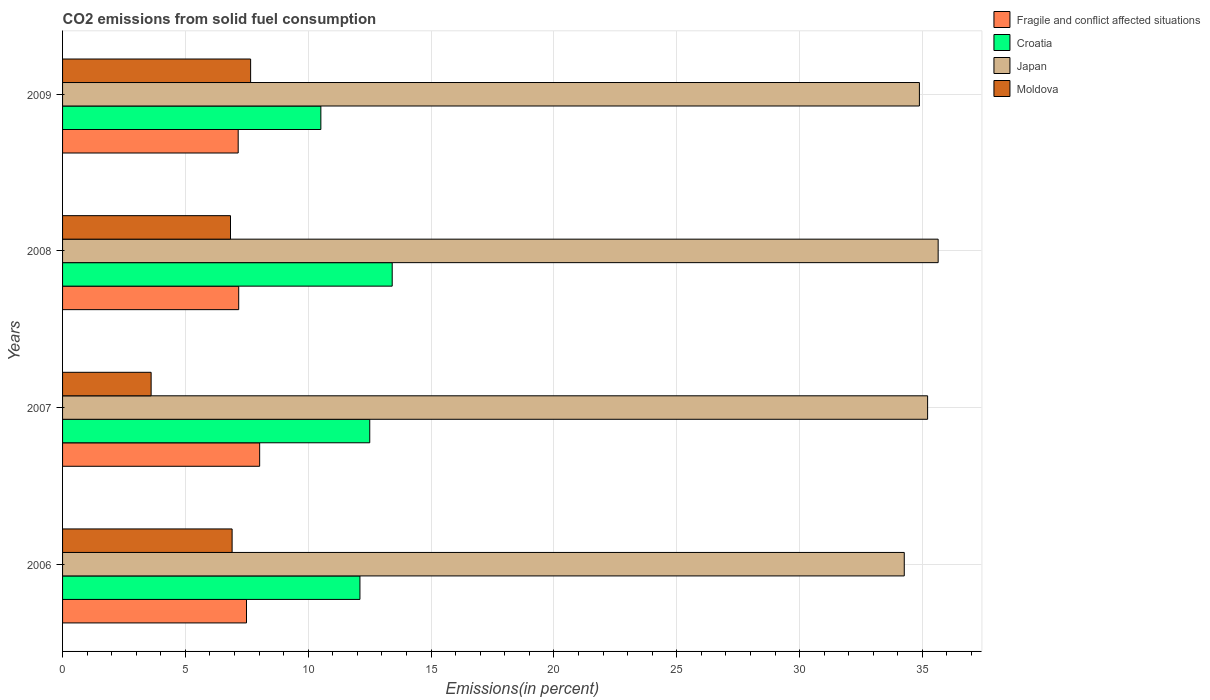Are the number of bars on each tick of the Y-axis equal?
Your answer should be very brief. Yes. How many bars are there on the 1st tick from the top?
Your answer should be compact. 4. What is the total CO2 emitted in Moldova in 2006?
Provide a succinct answer. 6.9. Across all years, what is the maximum total CO2 emitted in Croatia?
Your response must be concise. 13.42. Across all years, what is the minimum total CO2 emitted in Croatia?
Offer a terse response. 10.51. In which year was the total CO2 emitted in Japan maximum?
Make the answer very short. 2008. In which year was the total CO2 emitted in Fragile and conflict affected situations minimum?
Give a very brief answer. 2009. What is the total total CO2 emitted in Moldova in the graph?
Keep it short and to the point. 25. What is the difference between the total CO2 emitted in Moldova in 2006 and that in 2007?
Make the answer very short. 3.3. What is the difference between the total CO2 emitted in Fragile and conflict affected situations in 2006 and the total CO2 emitted in Moldova in 2008?
Make the answer very short. 0.65. What is the average total CO2 emitted in Moldova per year?
Give a very brief answer. 6.25. In the year 2009, what is the difference between the total CO2 emitted in Croatia and total CO2 emitted in Japan?
Give a very brief answer. -24.36. In how many years, is the total CO2 emitted in Fragile and conflict affected situations greater than 10 %?
Make the answer very short. 0. What is the ratio of the total CO2 emitted in Japan in 2006 to that in 2007?
Offer a very short reply. 0.97. Is the total CO2 emitted in Fragile and conflict affected situations in 2008 less than that in 2009?
Give a very brief answer. No. What is the difference between the highest and the second highest total CO2 emitted in Croatia?
Make the answer very short. 0.91. What is the difference between the highest and the lowest total CO2 emitted in Croatia?
Offer a very short reply. 2.9. In how many years, is the total CO2 emitted in Japan greater than the average total CO2 emitted in Japan taken over all years?
Your answer should be very brief. 2. Is the sum of the total CO2 emitted in Japan in 2006 and 2009 greater than the maximum total CO2 emitted in Moldova across all years?
Your answer should be very brief. Yes. Is it the case that in every year, the sum of the total CO2 emitted in Japan and total CO2 emitted in Croatia is greater than the sum of total CO2 emitted in Moldova and total CO2 emitted in Fragile and conflict affected situations?
Give a very brief answer. No. What does the 4th bar from the top in 2009 represents?
Your answer should be compact. Fragile and conflict affected situations. How many bars are there?
Give a very brief answer. 16. What is the difference between two consecutive major ticks on the X-axis?
Ensure brevity in your answer.  5. Does the graph contain any zero values?
Provide a succinct answer. No. Does the graph contain grids?
Make the answer very short. Yes. Where does the legend appear in the graph?
Provide a short and direct response. Top right. What is the title of the graph?
Offer a terse response. CO2 emissions from solid fuel consumption. Does "West Bank and Gaza" appear as one of the legend labels in the graph?
Keep it short and to the point. No. What is the label or title of the X-axis?
Your answer should be compact. Emissions(in percent). What is the Emissions(in percent) in Fragile and conflict affected situations in 2006?
Offer a terse response. 7.49. What is the Emissions(in percent) in Croatia in 2006?
Give a very brief answer. 12.1. What is the Emissions(in percent) of Japan in 2006?
Provide a short and direct response. 34.26. What is the Emissions(in percent) of Moldova in 2006?
Your answer should be compact. 6.9. What is the Emissions(in percent) of Fragile and conflict affected situations in 2007?
Provide a short and direct response. 8.02. What is the Emissions(in percent) of Croatia in 2007?
Keep it short and to the point. 12.5. What is the Emissions(in percent) in Japan in 2007?
Provide a succinct answer. 35.21. What is the Emissions(in percent) in Moldova in 2007?
Offer a terse response. 3.61. What is the Emissions(in percent) in Fragile and conflict affected situations in 2008?
Offer a terse response. 7.17. What is the Emissions(in percent) in Croatia in 2008?
Ensure brevity in your answer.  13.42. What is the Emissions(in percent) of Japan in 2008?
Provide a short and direct response. 35.64. What is the Emissions(in percent) of Moldova in 2008?
Give a very brief answer. 6.84. What is the Emissions(in percent) in Fragile and conflict affected situations in 2009?
Keep it short and to the point. 7.15. What is the Emissions(in percent) of Croatia in 2009?
Ensure brevity in your answer.  10.51. What is the Emissions(in percent) in Japan in 2009?
Offer a very short reply. 34.88. What is the Emissions(in percent) in Moldova in 2009?
Your answer should be very brief. 7.66. Across all years, what is the maximum Emissions(in percent) in Fragile and conflict affected situations?
Provide a short and direct response. 8.02. Across all years, what is the maximum Emissions(in percent) of Croatia?
Give a very brief answer. 13.42. Across all years, what is the maximum Emissions(in percent) of Japan?
Give a very brief answer. 35.64. Across all years, what is the maximum Emissions(in percent) of Moldova?
Your answer should be compact. 7.66. Across all years, what is the minimum Emissions(in percent) in Fragile and conflict affected situations?
Give a very brief answer. 7.15. Across all years, what is the minimum Emissions(in percent) of Croatia?
Your response must be concise. 10.51. Across all years, what is the minimum Emissions(in percent) of Japan?
Provide a succinct answer. 34.26. Across all years, what is the minimum Emissions(in percent) of Moldova?
Your response must be concise. 3.61. What is the total Emissions(in percent) of Fragile and conflict affected situations in the graph?
Make the answer very short. 29.83. What is the total Emissions(in percent) in Croatia in the graph?
Your answer should be compact. 48.54. What is the total Emissions(in percent) of Japan in the graph?
Ensure brevity in your answer.  139.99. What is the total Emissions(in percent) of Moldova in the graph?
Offer a very short reply. 25. What is the difference between the Emissions(in percent) of Fragile and conflict affected situations in 2006 and that in 2007?
Your response must be concise. -0.54. What is the difference between the Emissions(in percent) in Croatia in 2006 and that in 2007?
Keep it short and to the point. -0.4. What is the difference between the Emissions(in percent) of Japan in 2006 and that in 2007?
Offer a terse response. -0.95. What is the difference between the Emissions(in percent) in Moldova in 2006 and that in 2007?
Your answer should be compact. 3.3. What is the difference between the Emissions(in percent) of Fragile and conflict affected situations in 2006 and that in 2008?
Keep it short and to the point. 0.32. What is the difference between the Emissions(in percent) in Croatia in 2006 and that in 2008?
Give a very brief answer. -1.31. What is the difference between the Emissions(in percent) of Japan in 2006 and that in 2008?
Provide a succinct answer. -1.38. What is the difference between the Emissions(in percent) in Moldova in 2006 and that in 2008?
Provide a short and direct response. 0.07. What is the difference between the Emissions(in percent) of Fragile and conflict affected situations in 2006 and that in 2009?
Keep it short and to the point. 0.34. What is the difference between the Emissions(in percent) in Croatia in 2006 and that in 2009?
Offer a terse response. 1.59. What is the difference between the Emissions(in percent) of Japan in 2006 and that in 2009?
Offer a terse response. -0.62. What is the difference between the Emissions(in percent) of Moldova in 2006 and that in 2009?
Make the answer very short. -0.75. What is the difference between the Emissions(in percent) in Fragile and conflict affected situations in 2007 and that in 2008?
Your response must be concise. 0.85. What is the difference between the Emissions(in percent) of Croatia in 2007 and that in 2008?
Your answer should be very brief. -0.91. What is the difference between the Emissions(in percent) in Japan in 2007 and that in 2008?
Provide a succinct answer. -0.43. What is the difference between the Emissions(in percent) in Moldova in 2007 and that in 2008?
Your answer should be compact. -3.23. What is the difference between the Emissions(in percent) of Fragile and conflict affected situations in 2007 and that in 2009?
Make the answer very short. 0.87. What is the difference between the Emissions(in percent) in Croatia in 2007 and that in 2009?
Your answer should be compact. 1.99. What is the difference between the Emissions(in percent) in Japan in 2007 and that in 2009?
Your answer should be compact. 0.33. What is the difference between the Emissions(in percent) in Moldova in 2007 and that in 2009?
Your response must be concise. -4.05. What is the difference between the Emissions(in percent) in Fragile and conflict affected situations in 2008 and that in 2009?
Offer a very short reply. 0.02. What is the difference between the Emissions(in percent) in Croatia in 2008 and that in 2009?
Your answer should be very brief. 2.9. What is the difference between the Emissions(in percent) of Japan in 2008 and that in 2009?
Ensure brevity in your answer.  0.76. What is the difference between the Emissions(in percent) of Moldova in 2008 and that in 2009?
Ensure brevity in your answer.  -0.82. What is the difference between the Emissions(in percent) in Fragile and conflict affected situations in 2006 and the Emissions(in percent) in Croatia in 2007?
Offer a very short reply. -5.02. What is the difference between the Emissions(in percent) of Fragile and conflict affected situations in 2006 and the Emissions(in percent) of Japan in 2007?
Offer a terse response. -27.72. What is the difference between the Emissions(in percent) of Fragile and conflict affected situations in 2006 and the Emissions(in percent) of Moldova in 2007?
Offer a very short reply. 3.88. What is the difference between the Emissions(in percent) of Croatia in 2006 and the Emissions(in percent) of Japan in 2007?
Make the answer very short. -23.11. What is the difference between the Emissions(in percent) of Croatia in 2006 and the Emissions(in percent) of Moldova in 2007?
Give a very brief answer. 8.5. What is the difference between the Emissions(in percent) of Japan in 2006 and the Emissions(in percent) of Moldova in 2007?
Offer a very short reply. 30.66. What is the difference between the Emissions(in percent) of Fragile and conflict affected situations in 2006 and the Emissions(in percent) of Croatia in 2008?
Provide a short and direct response. -5.93. What is the difference between the Emissions(in percent) in Fragile and conflict affected situations in 2006 and the Emissions(in percent) in Japan in 2008?
Make the answer very short. -28.15. What is the difference between the Emissions(in percent) in Fragile and conflict affected situations in 2006 and the Emissions(in percent) in Moldova in 2008?
Your answer should be compact. 0.65. What is the difference between the Emissions(in percent) in Croatia in 2006 and the Emissions(in percent) in Japan in 2008?
Ensure brevity in your answer.  -23.54. What is the difference between the Emissions(in percent) of Croatia in 2006 and the Emissions(in percent) of Moldova in 2008?
Ensure brevity in your answer.  5.27. What is the difference between the Emissions(in percent) in Japan in 2006 and the Emissions(in percent) in Moldova in 2008?
Your answer should be compact. 27.43. What is the difference between the Emissions(in percent) in Fragile and conflict affected situations in 2006 and the Emissions(in percent) in Croatia in 2009?
Offer a terse response. -3.03. What is the difference between the Emissions(in percent) in Fragile and conflict affected situations in 2006 and the Emissions(in percent) in Japan in 2009?
Your answer should be compact. -27.39. What is the difference between the Emissions(in percent) in Fragile and conflict affected situations in 2006 and the Emissions(in percent) in Moldova in 2009?
Provide a short and direct response. -0.17. What is the difference between the Emissions(in percent) of Croatia in 2006 and the Emissions(in percent) of Japan in 2009?
Offer a terse response. -22.77. What is the difference between the Emissions(in percent) in Croatia in 2006 and the Emissions(in percent) in Moldova in 2009?
Ensure brevity in your answer.  4.45. What is the difference between the Emissions(in percent) of Japan in 2006 and the Emissions(in percent) of Moldova in 2009?
Keep it short and to the point. 26.61. What is the difference between the Emissions(in percent) of Fragile and conflict affected situations in 2007 and the Emissions(in percent) of Croatia in 2008?
Your answer should be compact. -5.4. What is the difference between the Emissions(in percent) of Fragile and conflict affected situations in 2007 and the Emissions(in percent) of Japan in 2008?
Offer a terse response. -27.62. What is the difference between the Emissions(in percent) of Fragile and conflict affected situations in 2007 and the Emissions(in percent) of Moldova in 2008?
Your answer should be compact. 1.19. What is the difference between the Emissions(in percent) of Croatia in 2007 and the Emissions(in percent) of Japan in 2008?
Offer a very short reply. -23.14. What is the difference between the Emissions(in percent) in Croatia in 2007 and the Emissions(in percent) in Moldova in 2008?
Give a very brief answer. 5.67. What is the difference between the Emissions(in percent) in Japan in 2007 and the Emissions(in percent) in Moldova in 2008?
Your answer should be very brief. 28.38. What is the difference between the Emissions(in percent) in Fragile and conflict affected situations in 2007 and the Emissions(in percent) in Croatia in 2009?
Ensure brevity in your answer.  -2.49. What is the difference between the Emissions(in percent) in Fragile and conflict affected situations in 2007 and the Emissions(in percent) in Japan in 2009?
Provide a succinct answer. -26.86. What is the difference between the Emissions(in percent) in Fragile and conflict affected situations in 2007 and the Emissions(in percent) in Moldova in 2009?
Give a very brief answer. 0.37. What is the difference between the Emissions(in percent) of Croatia in 2007 and the Emissions(in percent) of Japan in 2009?
Ensure brevity in your answer.  -22.37. What is the difference between the Emissions(in percent) of Croatia in 2007 and the Emissions(in percent) of Moldova in 2009?
Provide a short and direct response. 4.85. What is the difference between the Emissions(in percent) of Japan in 2007 and the Emissions(in percent) of Moldova in 2009?
Offer a very short reply. 27.56. What is the difference between the Emissions(in percent) in Fragile and conflict affected situations in 2008 and the Emissions(in percent) in Croatia in 2009?
Give a very brief answer. -3.34. What is the difference between the Emissions(in percent) of Fragile and conflict affected situations in 2008 and the Emissions(in percent) of Japan in 2009?
Your answer should be compact. -27.71. What is the difference between the Emissions(in percent) of Fragile and conflict affected situations in 2008 and the Emissions(in percent) of Moldova in 2009?
Give a very brief answer. -0.49. What is the difference between the Emissions(in percent) in Croatia in 2008 and the Emissions(in percent) in Japan in 2009?
Provide a succinct answer. -21.46. What is the difference between the Emissions(in percent) of Croatia in 2008 and the Emissions(in percent) of Moldova in 2009?
Your answer should be very brief. 5.76. What is the difference between the Emissions(in percent) of Japan in 2008 and the Emissions(in percent) of Moldova in 2009?
Provide a short and direct response. 27.99. What is the average Emissions(in percent) in Fragile and conflict affected situations per year?
Ensure brevity in your answer.  7.46. What is the average Emissions(in percent) in Croatia per year?
Your answer should be compact. 12.13. What is the average Emissions(in percent) of Japan per year?
Provide a short and direct response. 35. What is the average Emissions(in percent) of Moldova per year?
Offer a very short reply. 6.25. In the year 2006, what is the difference between the Emissions(in percent) of Fragile and conflict affected situations and Emissions(in percent) of Croatia?
Make the answer very short. -4.62. In the year 2006, what is the difference between the Emissions(in percent) in Fragile and conflict affected situations and Emissions(in percent) in Japan?
Give a very brief answer. -26.77. In the year 2006, what is the difference between the Emissions(in percent) in Fragile and conflict affected situations and Emissions(in percent) in Moldova?
Your answer should be compact. 0.59. In the year 2006, what is the difference between the Emissions(in percent) in Croatia and Emissions(in percent) in Japan?
Provide a short and direct response. -22.16. In the year 2006, what is the difference between the Emissions(in percent) in Croatia and Emissions(in percent) in Moldova?
Provide a short and direct response. 5.2. In the year 2006, what is the difference between the Emissions(in percent) in Japan and Emissions(in percent) in Moldova?
Provide a succinct answer. 27.36. In the year 2007, what is the difference between the Emissions(in percent) in Fragile and conflict affected situations and Emissions(in percent) in Croatia?
Offer a very short reply. -4.48. In the year 2007, what is the difference between the Emissions(in percent) in Fragile and conflict affected situations and Emissions(in percent) in Japan?
Ensure brevity in your answer.  -27.19. In the year 2007, what is the difference between the Emissions(in percent) of Fragile and conflict affected situations and Emissions(in percent) of Moldova?
Make the answer very short. 4.42. In the year 2007, what is the difference between the Emissions(in percent) of Croatia and Emissions(in percent) of Japan?
Offer a very short reply. -22.71. In the year 2007, what is the difference between the Emissions(in percent) of Croatia and Emissions(in percent) of Moldova?
Give a very brief answer. 8.9. In the year 2007, what is the difference between the Emissions(in percent) of Japan and Emissions(in percent) of Moldova?
Give a very brief answer. 31.61. In the year 2008, what is the difference between the Emissions(in percent) in Fragile and conflict affected situations and Emissions(in percent) in Croatia?
Give a very brief answer. -6.25. In the year 2008, what is the difference between the Emissions(in percent) of Fragile and conflict affected situations and Emissions(in percent) of Japan?
Your response must be concise. -28.47. In the year 2008, what is the difference between the Emissions(in percent) in Fragile and conflict affected situations and Emissions(in percent) in Moldova?
Your answer should be very brief. 0.33. In the year 2008, what is the difference between the Emissions(in percent) of Croatia and Emissions(in percent) of Japan?
Offer a terse response. -22.22. In the year 2008, what is the difference between the Emissions(in percent) of Croatia and Emissions(in percent) of Moldova?
Provide a short and direct response. 6.58. In the year 2008, what is the difference between the Emissions(in percent) in Japan and Emissions(in percent) in Moldova?
Ensure brevity in your answer.  28.81. In the year 2009, what is the difference between the Emissions(in percent) of Fragile and conflict affected situations and Emissions(in percent) of Croatia?
Make the answer very short. -3.37. In the year 2009, what is the difference between the Emissions(in percent) of Fragile and conflict affected situations and Emissions(in percent) of Japan?
Make the answer very short. -27.73. In the year 2009, what is the difference between the Emissions(in percent) in Fragile and conflict affected situations and Emissions(in percent) in Moldova?
Your answer should be compact. -0.51. In the year 2009, what is the difference between the Emissions(in percent) of Croatia and Emissions(in percent) of Japan?
Keep it short and to the point. -24.36. In the year 2009, what is the difference between the Emissions(in percent) in Croatia and Emissions(in percent) in Moldova?
Give a very brief answer. 2.86. In the year 2009, what is the difference between the Emissions(in percent) of Japan and Emissions(in percent) of Moldova?
Offer a very short reply. 27.22. What is the ratio of the Emissions(in percent) of Fragile and conflict affected situations in 2006 to that in 2007?
Keep it short and to the point. 0.93. What is the ratio of the Emissions(in percent) of Croatia in 2006 to that in 2007?
Provide a succinct answer. 0.97. What is the ratio of the Emissions(in percent) of Japan in 2006 to that in 2007?
Provide a short and direct response. 0.97. What is the ratio of the Emissions(in percent) in Moldova in 2006 to that in 2007?
Ensure brevity in your answer.  1.91. What is the ratio of the Emissions(in percent) of Fragile and conflict affected situations in 2006 to that in 2008?
Ensure brevity in your answer.  1.04. What is the ratio of the Emissions(in percent) in Croatia in 2006 to that in 2008?
Offer a very short reply. 0.9. What is the ratio of the Emissions(in percent) in Japan in 2006 to that in 2008?
Your answer should be compact. 0.96. What is the ratio of the Emissions(in percent) of Moldova in 2006 to that in 2008?
Provide a short and direct response. 1.01. What is the ratio of the Emissions(in percent) of Fragile and conflict affected situations in 2006 to that in 2009?
Give a very brief answer. 1.05. What is the ratio of the Emissions(in percent) in Croatia in 2006 to that in 2009?
Make the answer very short. 1.15. What is the ratio of the Emissions(in percent) of Japan in 2006 to that in 2009?
Offer a very short reply. 0.98. What is the ratio of the Emissions(in percent) in Moldova in 2006 to that in 2009?
Offer a terse response. 0.9. What is the ratio of the Emissions(in percent) in Fragile and conflict affected situations in 2007 to that in 2008?
Keep it short and to the point. 1.12. What is the ratio of the Emissions(in percent) of Croatia in 2007 to that in 2008?
Give a very brief answer. 0.93. What is the ratio of the Emissions(in percent) in Japan in 2007 to that in 2008?
Ensure brevity in your answer.  0.99. What is the ratio of the Emissions(in percent) in Moldova in 2007 to that in 2008?
Make the answer very short. 0.53. What is the ratio of the Emissions(in percent) in Fragile and conflict affected situations in 2007 to that in 2009?
Make the answer very short. 1.12. What is the ratio of the Emissions(in percent) in Croatia in 2007 to that in 2009?
Your answer should be very brief. 1.19. What is the ratio of the Emissions(in percent) in Japan in 2007 to that in 2009?
Offer a very short reply. 1.01. What is the ratio of the Emissions(in percent) in Moldova in 2007 to that in 2009?
Make the answer very short. 0.47. What is the ratio of the Emissions(in percent) in Croatia in 2008 to that in 2009?
Your response must be concise. 1.28. What is the ratio of the Emissions(in percent) of Japan in 2008 to that in 2009?
Your answer should be compact. 1.02. What is the ratio of the Emissions(in percent) in Moldova in 2008 to that in 2009?
Offer a terse response. 0.89. What is the difference between the highest and the second highest Emissions(in percent) of Fragile and conflict affected situations?
Keep it short and to the point. 0.54. What is the difference between the highest and the second highest Emissions(in percent) of Croatia?
Give a very brief answer. 0.91. What is the difference between the highest and the second highest Emissions(in percent) of Japan?
Your answer should be compact. 0.43. What is the difference between the highest and the second highest Emissions(in percent) in Moldova?
Keep it short and to the point. 0.75. What is the difference between the highest and the lowest Emissions(in percent) of Fragile and conflict affected situations?
Make the answer very short. 0.87. What is the difference between the highest and the lowest Emissions(in percent) of Croatia?
Offer a very short reply. 2.9. What is the difference between the highest and the lowest Emissions(in percent) in Japan?
Give a very brief answer. 1.38. What is the difference between the highest and the lowest Emissions(in percent) of Moldova?
Make the answer very short. 4.05. 